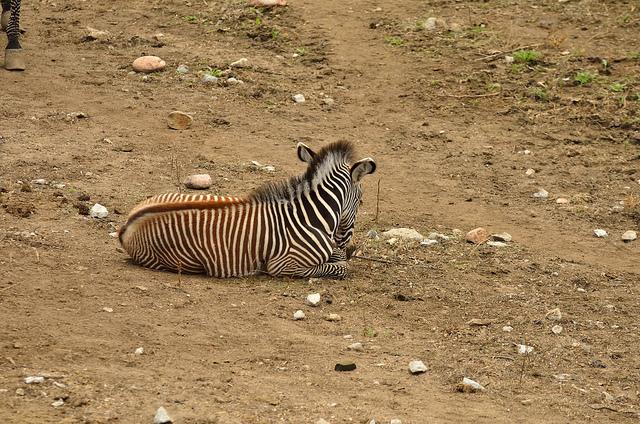Is this dirt rocky?
Write a very short answer. Yes. What position is the animal in?
Concise answer only. Laying down. Is the animal active?
Keep it brief. No. What is the color of the zebra?
Quick response, please. Black and white. 